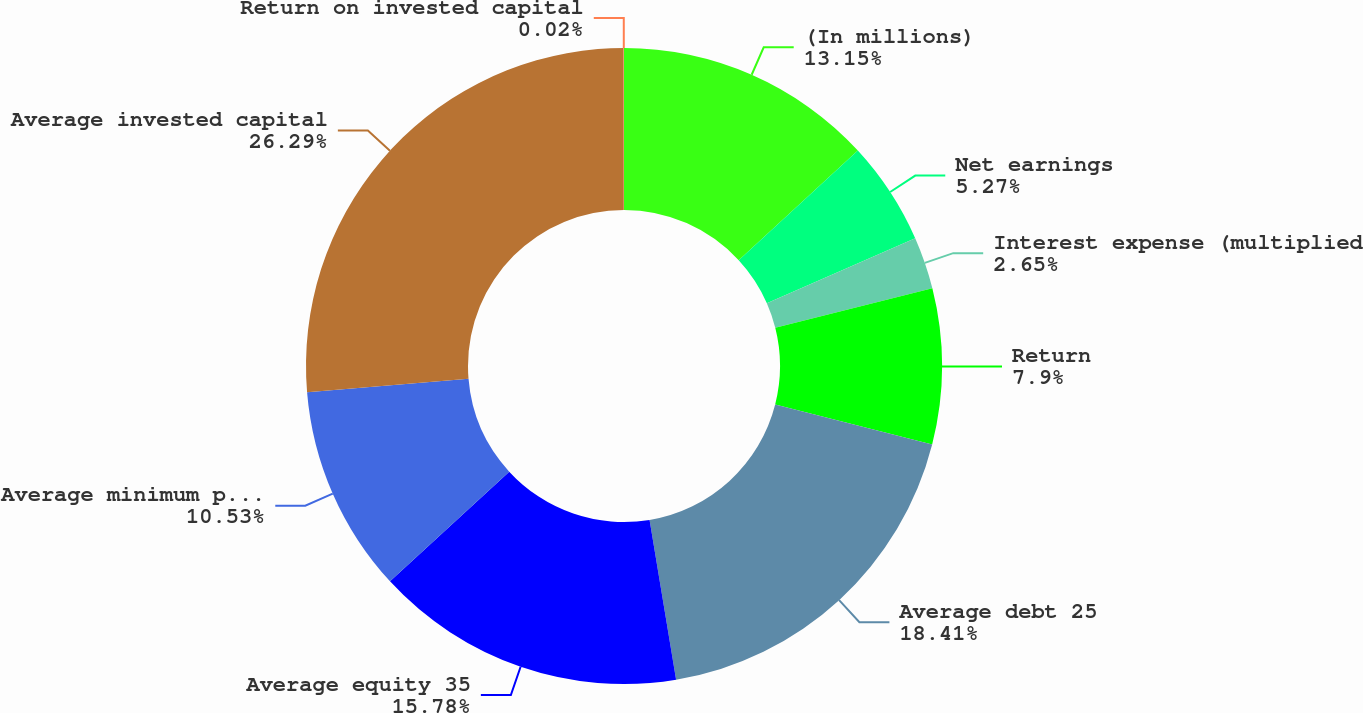Convert chart. <chart><loc_0><loc_0><loc_500><loc_500><pie_chart><fcel>(In millions)<fcel>Net earnings<fcel>Interest expense (multiplied<fcel>Return<fcel>Average debt 25<fcel>Average equity 35<fcel>Average minimum pension<fcel>Average invested capital<fcel>Return on invested capital<nl><fcel>13.15%<fcel>5.27%<fcel>2.65%<fcel>7.9%<fcel>18.41%<fcel>15.78%<fcel>10.53%<fcel>26.29%<fcel>0.02%<nl></chart> 